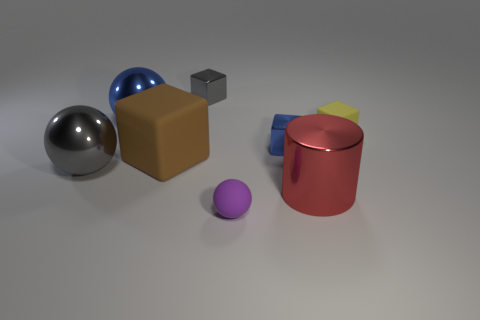Subtract all gray blocks. How many blocks are left? 3 Subtract 1 cubes. How many cubes are left? 3 Subtract all brown cubes. How many cubes are left? 3 Subtract all cyan cubes. Subtract all brown spheres. How many cubes are left? 4 Add 1 brown matte cubes. How many objects exist? 9 Subtract all cylinders. How many objects are left? 7 Add 5 tiny cyan metal things. How many tiny cyan metal things exist? 5 Subtract 0 yellow balls. How many objects are left? 8 Subtract all small yellow shiny things. Subtract all brown matte cubes. How many objects are left? 7 Add 1 purple objects. How many purple objects are left? 2 